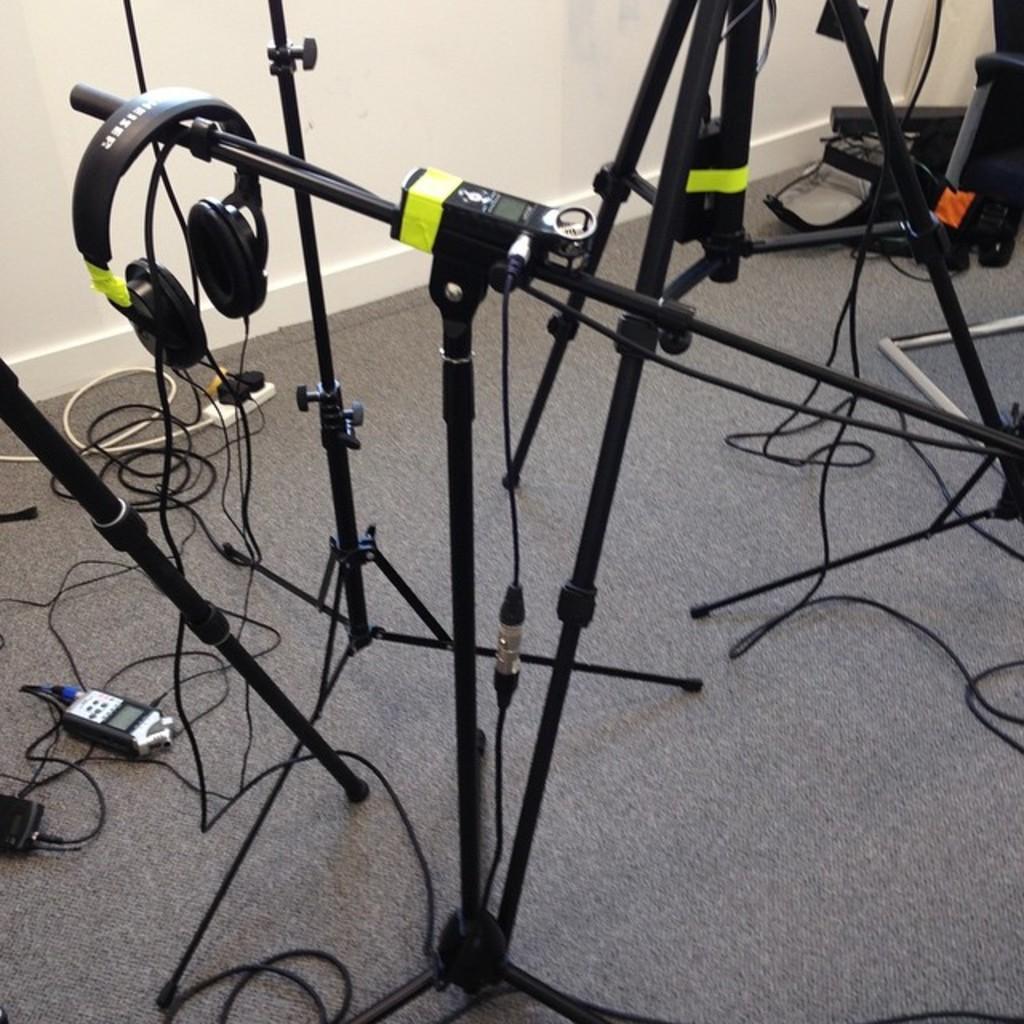Describe this image in one or two sentences. In this picture I can see few tripods and I can see few wires. On the left side of this picture I can see an electronic device and a headphone. In the background I can see the wall. On the right top of this picture I can see few things. 